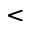<formula> <loc_0><loc_0><loc_500><loc_500><</formula> 